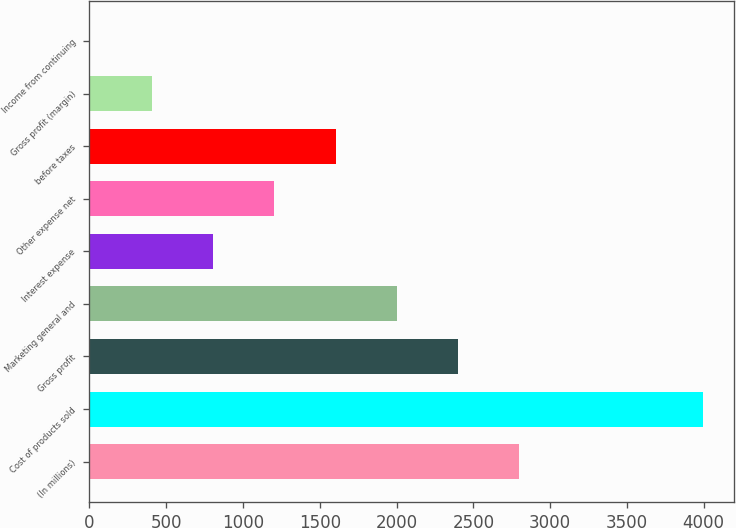<chart> <loc_0><loc_0><loc_500><loc_500><bar_chart><fcel>(In millions)<fcel>Cost of products sold<fcel>Gross profit<fcel>Marketing general and<fcel>Interest expense<fcel>Other expense net<fcel>before taxes<fcel>Gross profit (margin)<fcel>Income from continuing<nl><fcel>2799.63<fcel>3996.6<fcel>2400.64<fcel>2001.65<fcel>804.68<fcel>1203.67<fcel>1602.66<fcel>405.69<fcel>6.7<nl></chart> 